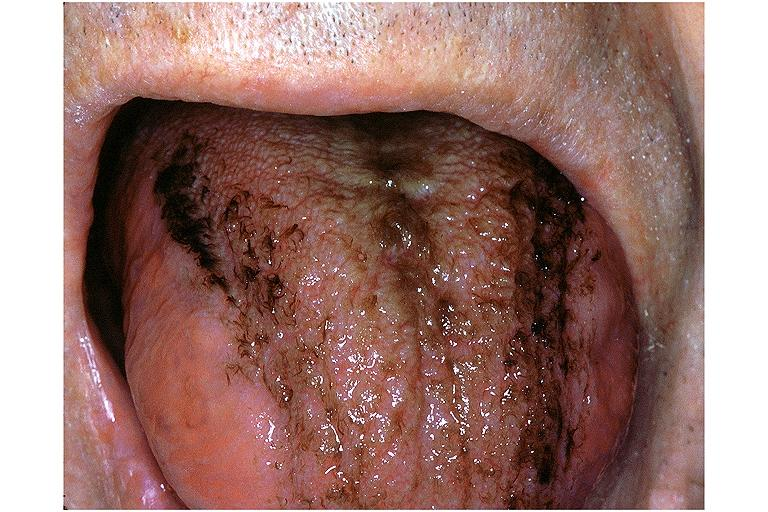what does this image show?
Answer the question using a single word or phrase. Black hairy tongue 